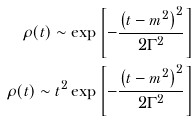Convert formula to latex. <formula><loc_0><loc_0><loc_500><loc_500>\rho ( t ) \sim \exp { \left [ - \frac { \left ( t - m ^ { 2 } \right ) ^ { 2 } } { 2 \Gamma ^ { 2 } } \right ] } \\ \rho ( t ) \sim t ^ { 2 } \exp { \left [ - \frac { \left ( t - m ^ { 2 } \right ) ^ { 2 } } { 2 \Gamma ^ { 2 } } \right ] }</formula> 